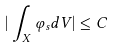<formula> <loc_0><loc_0><loc_500><loc_500>| \int _ { X } \varphi _ { s } d V | \leq C</formula> 